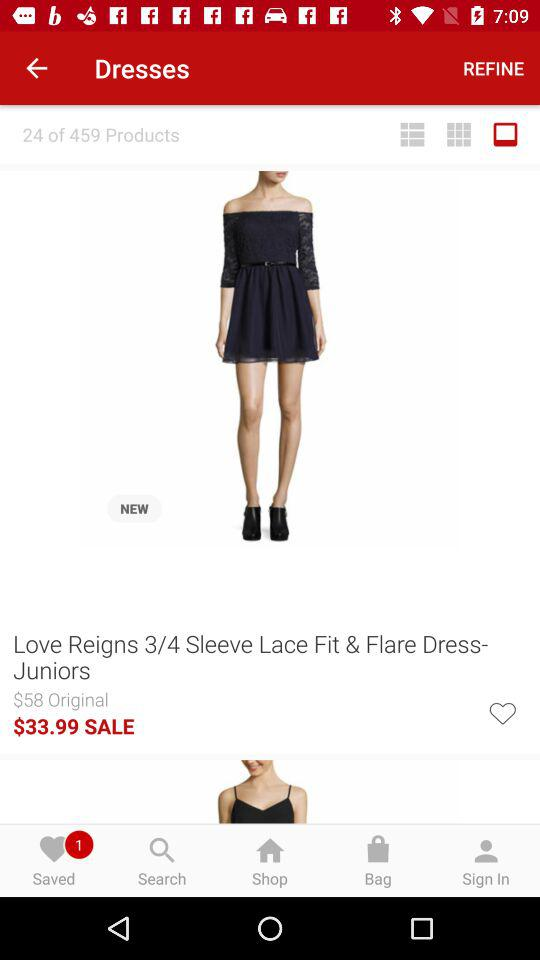In what sizes is the dress available?
When the provided information is insufficient, respond with <no answer>. <no answer> 